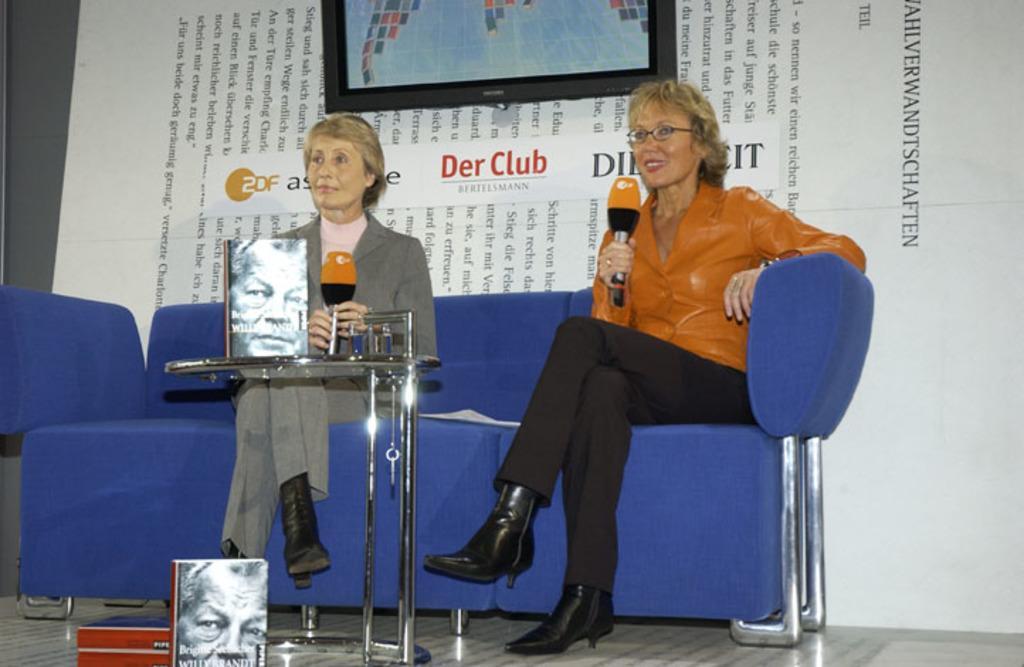Describe this image in one or two sentences. In this image I can see two women are sitting on a blue colour sofa and I can see both of them are holding mics. In the front of them I can see a table and on it I can see a book. In the background I can see a white colour board, a television and on the board I can see something is written. I can also see three more books on the bottom left side of this image. 